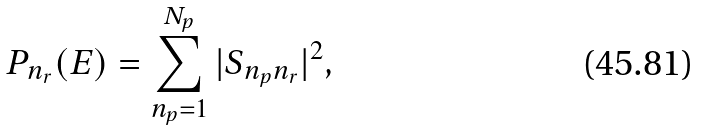Convert formula to latex. <formula><loc_0><loc_0><loc_500><loc_500>P _ { n _ { r } } ( E ) = \sum _ { n _ { p } = 1 } ^ { N _ { p } } | S _ { n _ { p } n _ { r } } | ^ { 2 } ,</formula> 